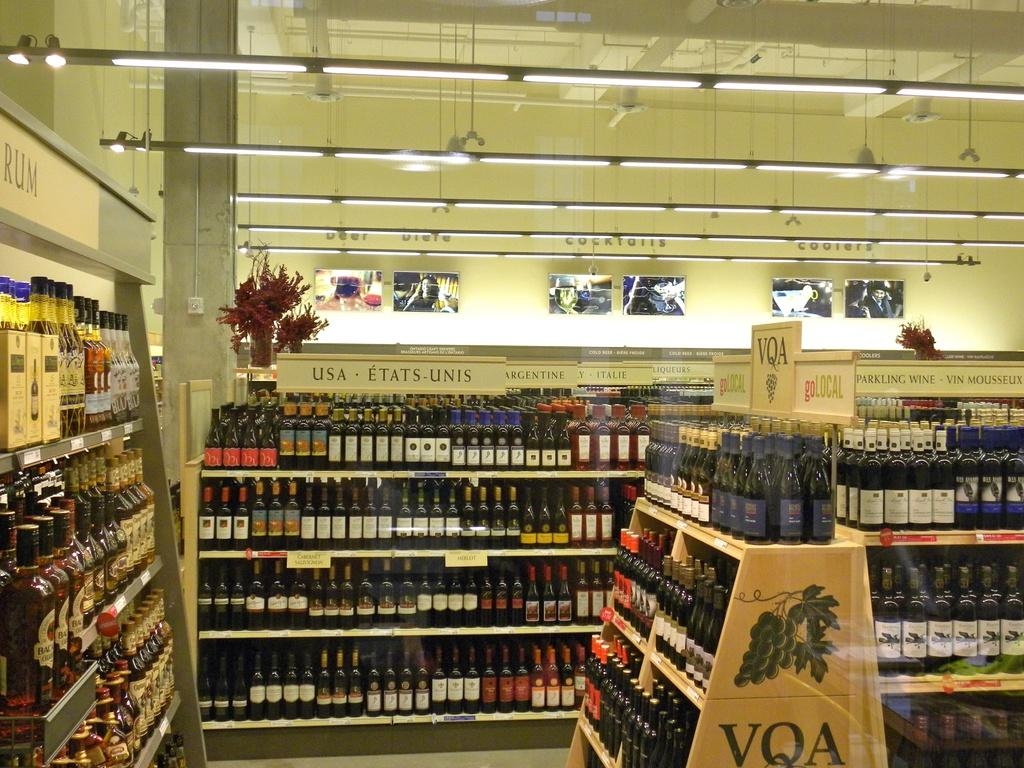<image>
Render a clear and concise summary of the photo. A in store display of many wine bottles and one display says VQA on it. 